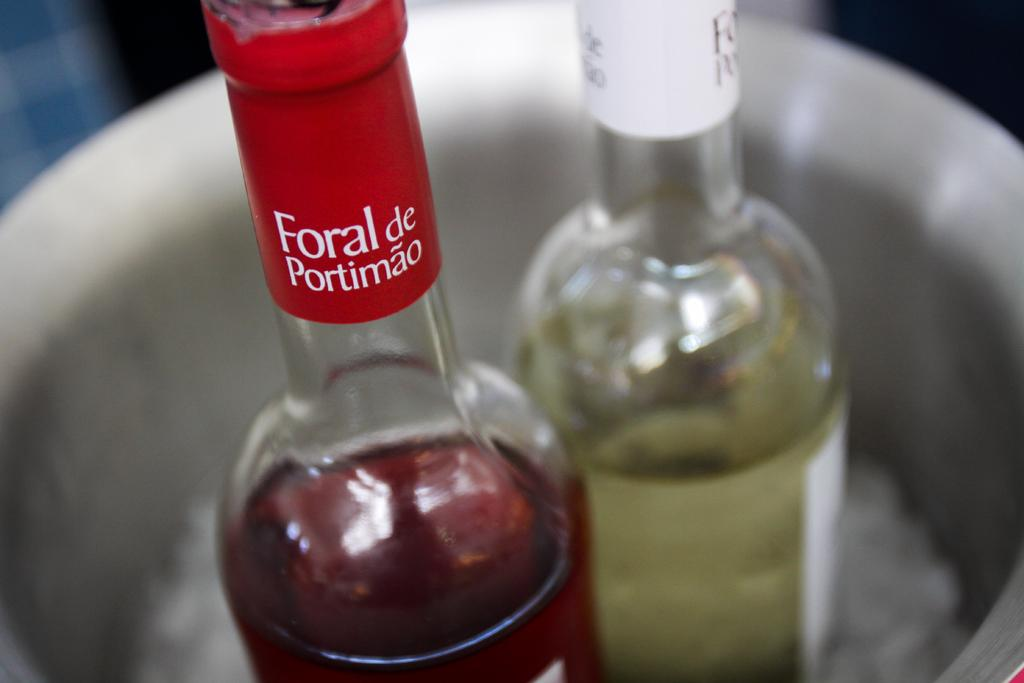How many bottles can be seen in the image? There are two bottles in the image. Where are the bottles located in the image? The bottles are in a container. What type of bell can be heard ringing in the image? There is no bell present in the image, so it is not possible to hear it ringing. 